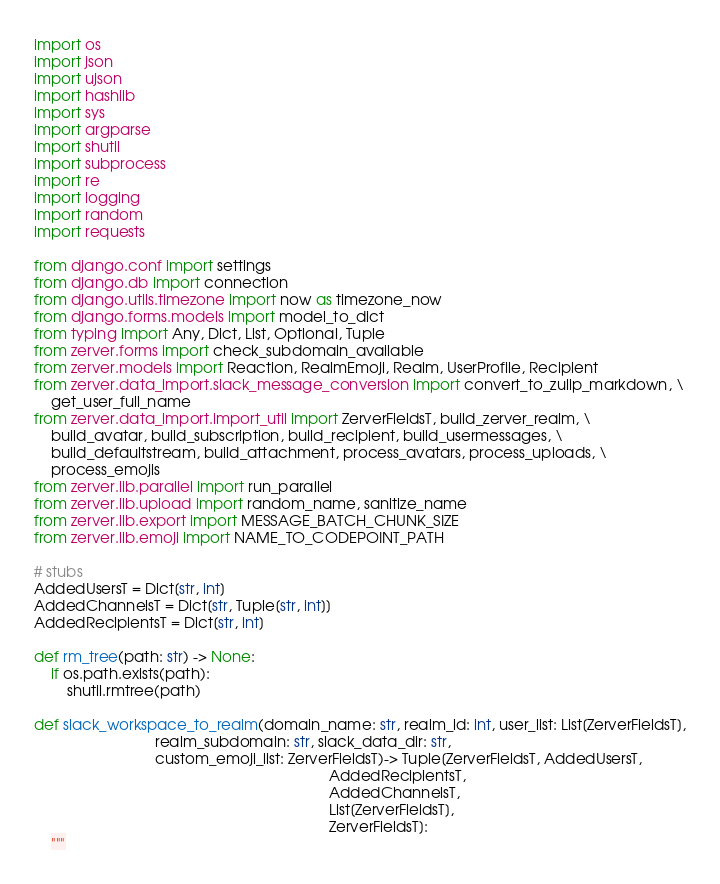Convert code to text. <code><loc_0><loc_0><loc_500><loc_500><_Python_>import os
import json
import ujson
import hashlib
import sys
import argparse
import shutil
import subprocess
import re
import logging
import random
import requests

from django.conf import settings
from django.db import connection
from django.utils.timezone import now as timezone_now
from django.forms.models import model_to_dict
from typing import Any, Dict, List, Optional, Tuple
from zerver.forms import check_subdomain_available
from zerver.models import Reaction, RealmEmoji, Realm, UserProfile, Recipient
from zerver.data_import.slack_message_conversion import convert_to_zulip_markdown, \
    get_user_full_name
from zerver.data_import.import_util import ZerverFieldsT, build_zerver_realm, \
    build_avatar, build_subscription, build_recipient, build_usermessages, \
    build_defaultstream, build_attachment, process_avatars, process_uploads, \
    process_emojis
from zerver.lib.parallel import run_parallel
from zerver.lib.upload import random_name, sanitize_name
from zerver.lib.export import MESSAGE_BATCH_CHUNK_SIZE
from zerver.lib.emoji import NAME_TO_CODEPOINT_PATH

# stubs
AddedUsersT = Dict[str, int]
AddedChannelsT = Dict[str, Tuple[str, int]]
AddedRecipientsT = Dict[str, int]

def rm_tree(path: str) -> None:
    if os.path.exists(path):
        shutil.rmtree(path)

def slack_workspace_to_realm(domain_name: str, realm_id: int, user_list: List[ZerverFieldsT],
                             realm_subdomain: str, slack_data_dir: str,
                             custom_emoji_list: ZerverFieldsT)-> Tuple[ZerverFieldsT, AddedUsersT,
                                                                       AddedRecipientsT,
                                                                       AddedChannelsT,
                                                                       List[ZerverFieldsT],
                                                                       ZerverFieldsT]:
    """</code> 